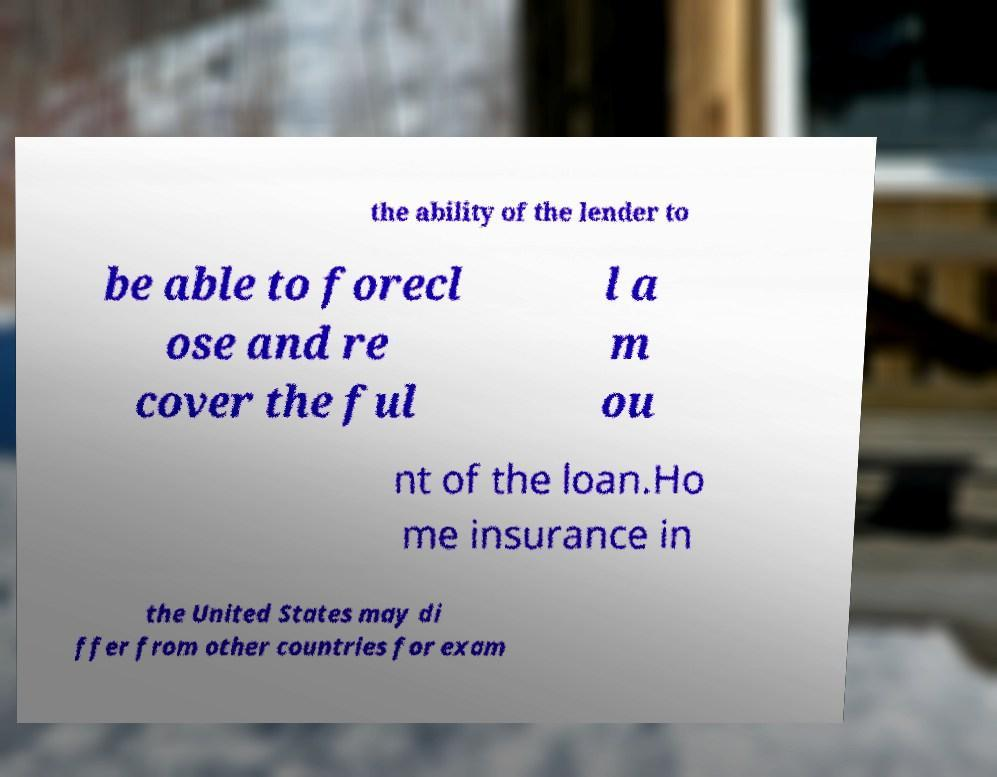Please read and relay the text visible in this image. What does it say? the ability of the lender to be able to forecl ose and re cover the ful l a m ou nt of the loan.Ho me insurance in the United States may di ffer from other countries for exam 